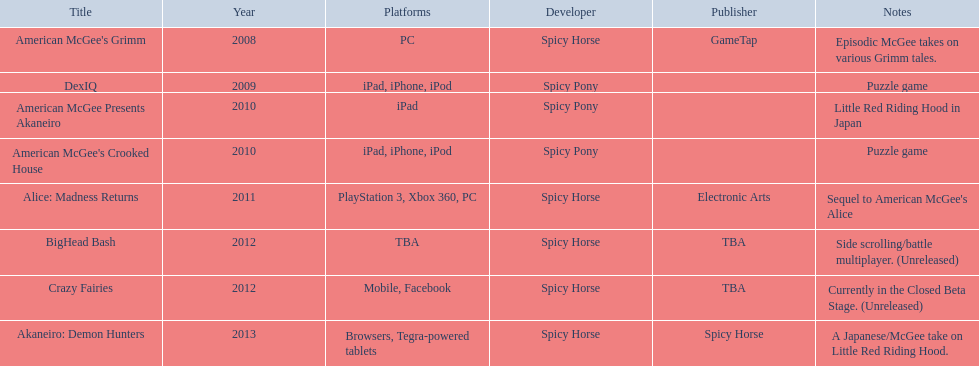Can you list the titles of all games that have been published? American McGee's Grimm, DexIQ, American McGee Presents Akaneiro, American McGee's Crooked House, Alice: Madness Returns, BigHead Bash, Crazy Fairies, Akaneiro: Demon Hunters. Who are the names of all the publishers? GameTap, , , , Electronic Arts, TBA, TBA, Spicy Horse. What is the game title related to electronic arts? Alice: Madness Returns. 